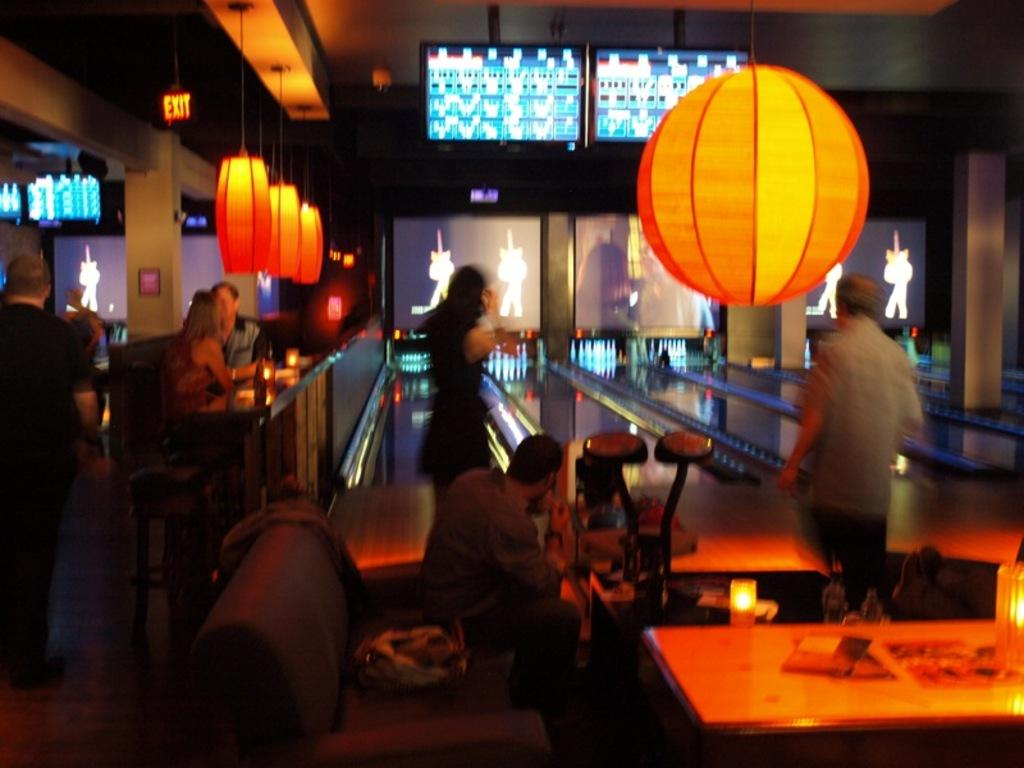What is located on top in the image? There are screens on top in the image. What are the people in the image doing? There are persons sitting and three persons standing in the image. Can you describe an object on a table in the image? There is a book on a table in the image. What type of profit can be seen in the image? There is no mention of profit in the image; it features screens, sitting persons, standing persons, and a book on a table. What kind of sign is present in the image? There is no sign present in the image. 